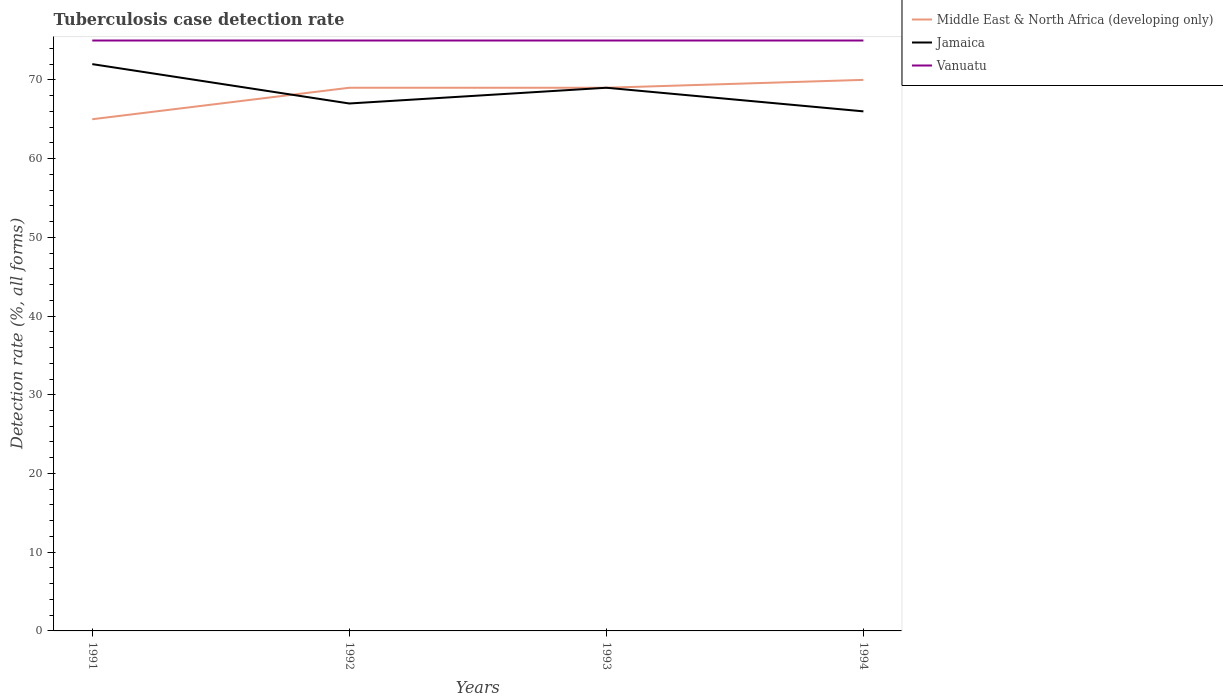Is the number of lines equal to the number of legend labels?
Your response must be concise. Yes. Across all years, what is the maximum tuberculosis case detection rate in in Jamaica?
Your answer should be very brief. 66. In which year was the tuberculosis case detection rate in in Vanuatu maximum?
Your answer should be very brief. 1991. What is the difference between the highest and the second highest tuberculosis case detection rate in in Middle East & North Africa (developing only)?
Your answer should be compact. 5. What is the difference between the highest and the lowest tuberculosis case detection rate in in Middle East & North Africa (developing only)?
Keep it short and to the point. 3. How many years are there in the graph?
Make the answer very short. 4. What is the difference between two consecutive major ticks on the Y-axis?
Your response must be concise. 10. Does the graph contain any zero values?
Offer a terse response. No. How are the legend labels stacked?
Provide a short and direct response. Vertical. What is the title of the graph?
Give a very brief answer. Tuberculosis case detection rate. What is the label or title of the Y-axis?
Provide a short and direct response. Detection rate (%, all forms). What is the Detection rate (%, all forms) of Middle East & North Africa (developing only) in 1992?
Ensure brevity in your answer.  69. What is the Detection rate (%, all forms) in Middle East & North Africa (developing only) in 1993?
Give a very brief answer. 69. What is the Detection rate (%, all forms) in Jamaica in 1993?
Ensure brevity in your answer.  69. What is the Detection rate (%, all forms) of Vanuatu in 1993?
Offer a terse response. 75. Across all years, what is the maximum Detection rate (%, all forms) in Middle East & North Africa (developing only)?
Ensure brevity in your answer.  70. Across all years, what is the maximum Detection rate (%, all forms) in Jamaica?
Offer a terse response. 72. Across all years, what is the maximum Detection rate (%, all forms) of Vanuatu?
Your response must be concise. 75. Across all years, what is the minimum Detection rate (%, all forms) of Jamaica?
Offer a terse response. 66. Across all years, what is the minimum Detection rate (%, all forms) of Vanuatu?
Your answer should be very brief. 75. What is the total Detection rate (%, all forms) in Middle East & North Africa (developing only) in the graph?
Give a very brief answer. 273. What is the total Detection rate (%, all forms) of Jamaica in the graph?
Make the answer very short. 274. What is the total Detection rate (%, all forms) in Vanuatu in the graph?
Offer a terse response. 300. What is the difference between the Detection rate (%, all forms) in Middle East & North Africa (developing only) in 1991 and that in 1992?
Keep it short and to the point. -4. What is the difference between the Detection rate (%, all forms) in Jamaica in 1991 and that in 1992?
Ensure brevity in your answer.  5. What is the difference between the Detection rate (%, all forms) in Middle East & North Africa (developing only) in 1991 and that in 1993?
Give a very brief answer. -4. What is the difference between the Detection rate (%, all forms) in Jamaica in 1991 and that in 1994?
Your response must be concise. 6. What is the difference between the Detection rate (%, all forms) of Middle East & North Africa (developing only) in 1992 and that in 1993?
Give a very brief answer. 0. What is the difference between the Detection rate (%, all forms) in Jamaica in 1992 and that in 1993?
Offer a very short reply. -2. What is the difference between the Detection rate (%, all forms) of Vanuatu in 1992 and that in 1993?
Your response must be concise. 0. What is the difference between the Detection rate (%, all forms) in Middle East & North Africa (developing only) in 1992 and that in 1994?
Make the answer very short. -1. What is the difference between the Detection rate (%, all forms) in Vanuatu in 1993 and that in 1994?
Keep it short and to the point. 0. What is the difference between the Detection rate (%, all forms) in Middle East & North Africa (developing only) in 1991 and the Detection rate (%, all forms) in Jamaica in 1992?
Provide a short and direct response. -2. What is the difference between the Detection rate (%, all forms) in Jamaica in 1991 and the Detection rate (%, all forms) in Vanuatu in 1992?
Make the answer very short. -3. What is the difference between the Detection rate (%, all forms) in Jamaica in 1991 and the Detection rate (%, all forms) in Vanuatu in 1993?
Offer a terse response. -3. What is the difference between the Detection rate (%, all forms) of Jamaica in 1991 and the Detection rate (%, all forms) of Vanuatu in 1994?
Your response must be concise. -3. What is the difference between the Detection rate (%, all forms) of Middle East & North Africa (developing only) in 1992 and the Detection rate (%, all forms) of Jamaica in 1994?
Offer a terse response. 3. What is the difference between the Detection rate (%, all forms) of Jamaica in 1992 and the Detection rate (%, all forms) of Vanuatu in 1994?
Provide a succinct answer. -8. What is the difference between the Detection rate (%, all forms) in Middle East & North Africa (developing only) in 1993 and the Detection rate (%, all forms) in Vanuatu in 1994?
Make the answer very short. -6. What is the average Detection rate (%, all forms) in Middle East & North Africa (developing only) per year?
Provide a short and direct response. 68.25. What is the average Detection rate (%, all forms) in Jamaica per year?
Provide a short and direct response. 68.5. What is the average Detection rate (%, all forms) of Vanuatu per year?
Make the answer very short. 75. In the year 1991, what is the difference between the Detection rate (%, all forms) in Jamaica and Detection rate (%, all forms) in Vanuatu?
Provide a short and direct response. -3. In the year 1992, what is the difference between the Detection rate (%, all forms) in Middle East & North Africa (developing only) and Detection rate (%, all forms) in Vanuatu?
Make the answer very short. -6. In the year 1993, what is the difference between the Detection rate (%, all forms) of Middle East & North Africa (developing only) and Detection rate (%, all forms) of Jamaica?
Your answer should be compact. 0. In the year 1993, what is the difference between the Detection rate (%, all forms) of Jamaica and Detection rate (%, all forms) of Vanuatu?
Keep it short and to the point. -6. In the year 1994, what is the difference between the Detection rate (%, all forms) in Middle East & North Africa (developing only) and Detection rate (%, all forms) in Vanuatu?
Offer a very short reply. -5. What is the ratio of the Detection rate (%, all forms) in Middle East & North Africa (developing only) in 1991 to that in 1992?
Provide a succinct answer. 0.94. What is the ratio of the Detection rate (%, all forms) in Jamaica in 1991 to that in 1992?
Ensure brevity in your answer.  1.07. What is the ratio of the Detection rate (%, all forms) in Middle East & North Africa (developing only) in 1991 to that in 1993?
Offer a very short reply. 0.94. What is the ratio of the Detection rate (%, all forms) of Jamaica in 1991 to that in 1993?
Provide a short and direct response. 1.04. What is the ratio of the Detection rate (%, all forms) of Vanuatu in 1991 to that in 1993?
Make the answer very short. 1. What is the ratio of the Detection rate (%, all forms) of Jamaica in 1991 to that in 1994?
Offer a very short reply. 1.09. What is the ratio of the Detection rate (%, all forms) of Vanuatu in 1991 to that in 1994?
Provide a short and direct response. 1. What is the ratio of the Detection rate (%, all forms) in Middle East & North Africa (developing only) in 1992 to that in 1993?
Your answer should be compact. 1. What is the ratio of the Detection rate (%, all forms) of Jamaica in 1992 to that in 1993?
Your response must be concise. 0.97. What is the ratio of the Detection rate (%, all forms) of Middle East & North Africa (developing only) in 1992 to that in 1994?
Your response must be concise. 0.99. What is the ratio of the Detection rate (%, all forms) of Jamaica in 1992 to that in 1994?
Make the answer very short. 1.02. What is the ratio of the Detection rate (%, all forms) in Middle East & North Africa (developing only) in 1993 to that in 1994?
Keep it short and to the point. 0.99. What is the ratio of the Detection rate (%, all forms) of Jamaica in 1993 to that in 1994?
Give a very brief answer. 1.05. What is the ratio of the Detection rate (%, all forms) of Vanuatu in 1993 to that in 1994?
Your response must be concise. 1. What is the difference between the highest and the second highest Detection rate (%, all forms) in Middle East & North Africa (developing only)?
Offer a very short reply. 1. What is the difference between the highest and the second highest Detection rate (%, all forms) in Jamaica?
Provide a short and direct response. 3. What is the difference between the highest and the second highest Detection rate (%, all forms) of Vanuatu?
Keep it short and to the point. 0. What is the difference between the highest and the lowest Detection rate (%, all forms) of Middle East & North Africa (developing only)?
Keep it short and to the point. 5. 